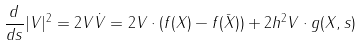<formula> <loc_0><loc_0><loc_500><loc_500>\frac { d } { d s } | V | ^ { 2 } = 2 V \dot { V } = 2 V \cdot ( f ( X ) - f ( \bar { X } ) ) + 2 h ^ { 2 } V \cdot g ( X , s )</formula> 